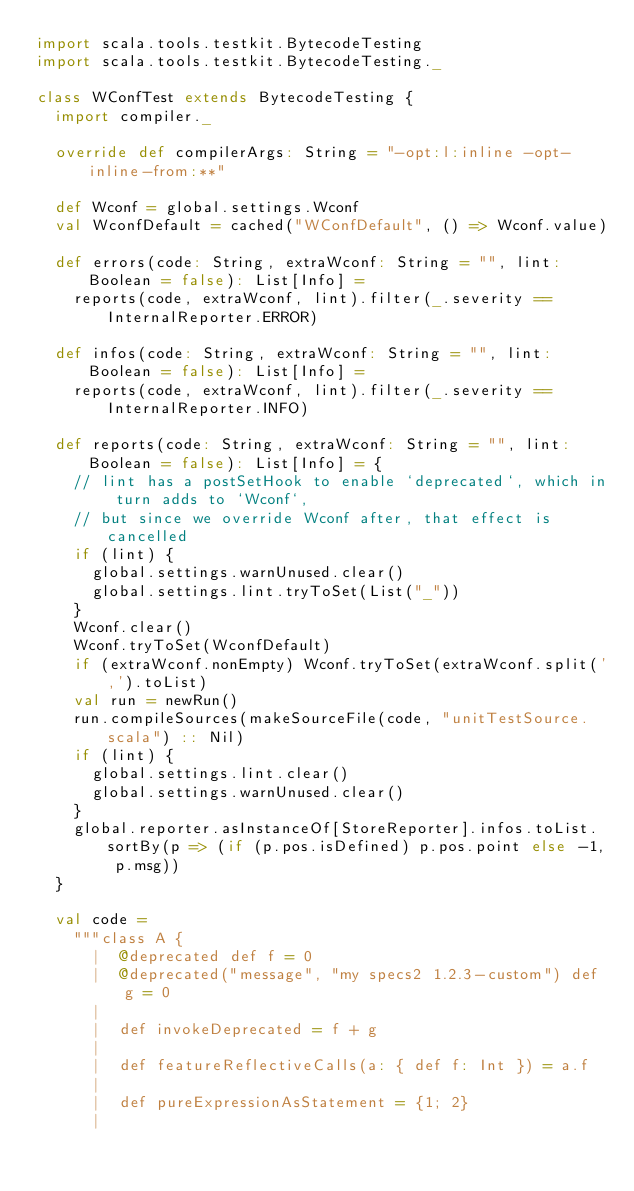<code> <loc_0><loc_0><loc_500><loc_500><_Scala_>import scala.tools.testkit.BytecodeTesting
import scala.tools.testkit.BytecodeTesting._

class WConfTest extends BytecodeTesting {
  import compiler._

  override def compilerArgs: String = "-opt:l:inline -opt-inline-from:**"

  def Wconf = global.settings.Wconf
  val WconfDefault = cached("WConfDefault", () => Wconf.value)

  def errors(code: String, extraWconf: String = "", lint: Boolean = false): List[Info] =
    reports(code, extraWconf, lint).filter(_.severity == InternalReporter.ERROR)

  def infos(code: String, extraWconf: String = "", lint: Boolean = false): List[Info] =
    reports(code, extraWconf, lint).filter(_.severity == InternalReporter.INFO)

  def reports(code: String, extraWconf: String = "", lint: Boolean = false): List[Info] = {
    // lint has a postSetHook to enable `deprecated`, which in turn adds to `Wconf`,
    // but since we override Wconf after, that effect is cancelled
    if (lint) {
      global.settings.warnUnused.clear()
      global.settings.lint.tryToSet(List("_"))
    }
    Wconf.clear()
    Wconf.tryToSet(WconfDefault)
    if (extraWconf.nonEmpty) Wconf.tryToSet(extraWconf.split(',').toList)
    val run = newRun()
    run.compileSources(makeSourceFile(code, "unitTestSource.scala") :: Nil)
    if (lint) {
      global.settings.lint.clear()
      global.settings.warnUnused.clear()
    }
    global.reporter.asInstanceOf[StoreReporter].infos.toList.sortBy(p => (if (p.pos.isDefined) p.pos.point else -1, p.msg))
  }

  val code =
    """class A {
      |  @deprecated def f = 0
      |  @deprecated("message", "my specs2 1.2.3-custom") def g = 0
      |
      |  def invokeDeprecated = f + g
      |
      |  def featureReflectiveCalls(a: { def f: Int }) = a.f
      |
      |  def pureExpressionAsStatement = {1; 2}
      |</code> 